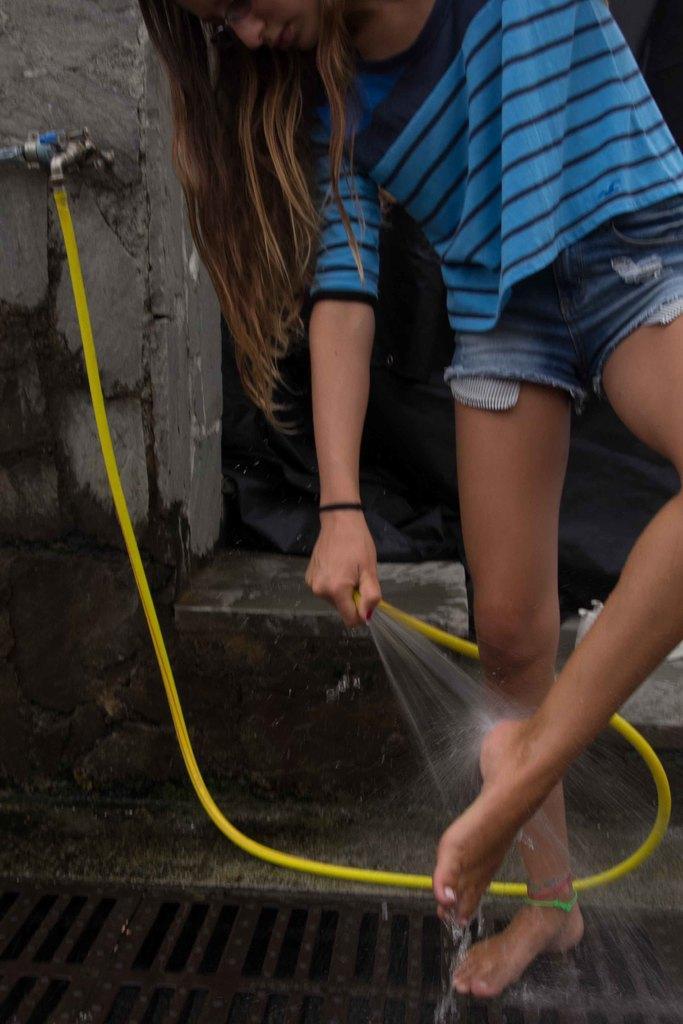Describe this image in one or two sentences. In this picture we can see a girl holding a pipe with her hand and standing on a mesh, tap, water. 